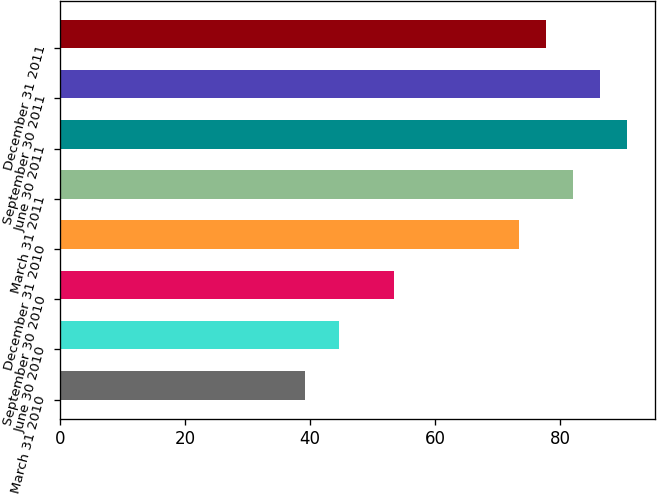Convert chart to OTSL. <chart><loc_0><loc_0><loc_500><loc_500><bar_chart><fcel>March 31 2010<fcel>June 30 2010<fcel>September 30 2010<fcel>December 31 2010<fcel>March 31 2011<fcel>June 30 2011<fcel>September 30 2011<fcel>December 31 2011<nl><fcel>39.21<fcel>44.55<fcel>53.42<fcel>73.43<fcel>82.05<fcel>90.67<fcel>86.36<fcel>77.74<nl></chart> 